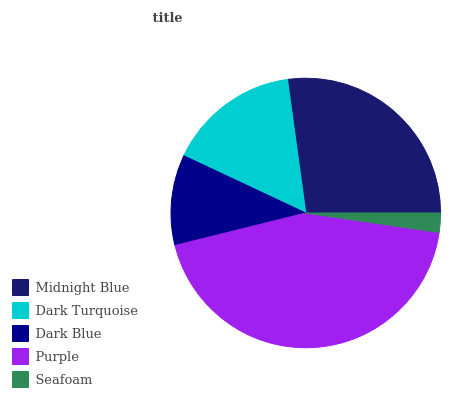Is Seafoam the minimum?
Answer yes or no. Yes. Is Purple the maximum?
Answer yes or no. Yes. Is Dark Turquoise the minimum?
Answer yes or no. No. Is Dark Turquoise the maximum?
Answer yes or no. No. Is Midnight Blue greater than Dark Turquoise?
Answer yes or no. Yes. Is Dark Turquoise less than Midnight Blue?
Answer yes or no. Yes. Is Dark Turquoise greater than Midnight Blue?
Answer yes or no. No. Is Midnight Blue less than Dark Turquoise?
Answer yes or no. No. Is Dark Turquoise the high median?
Answer yes or no. Yes. Is Dark Turquoise the low median?
Answer yes or no. Yes. Is Midnight Blue the high median?
Answer yes or no. No. Is Midnight Blue the low median?
Answer yes or no. No. 